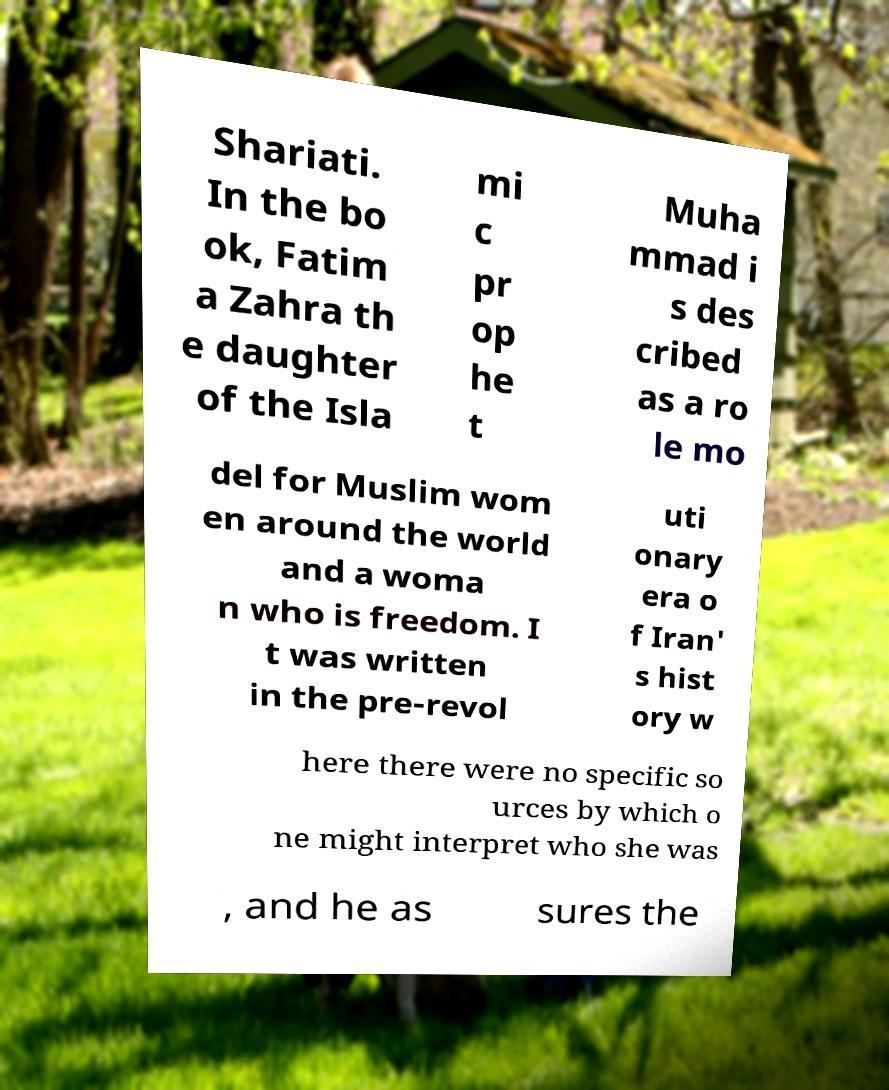Please read and relay the text visible in this image. What does it say? Shariati. In the bo ok, Fatim a Zahra th e daughter of the Isla mi c pr op he t Muha mmad i s des cribed as a ro le mo del for Muslim wom en around the world and a woma n who is freedom. I t was written in the pre-revol uti onary era o f Iran' s hist ory w here there were no specific so urces by which o ne might interpret who she was , and he as sures the 